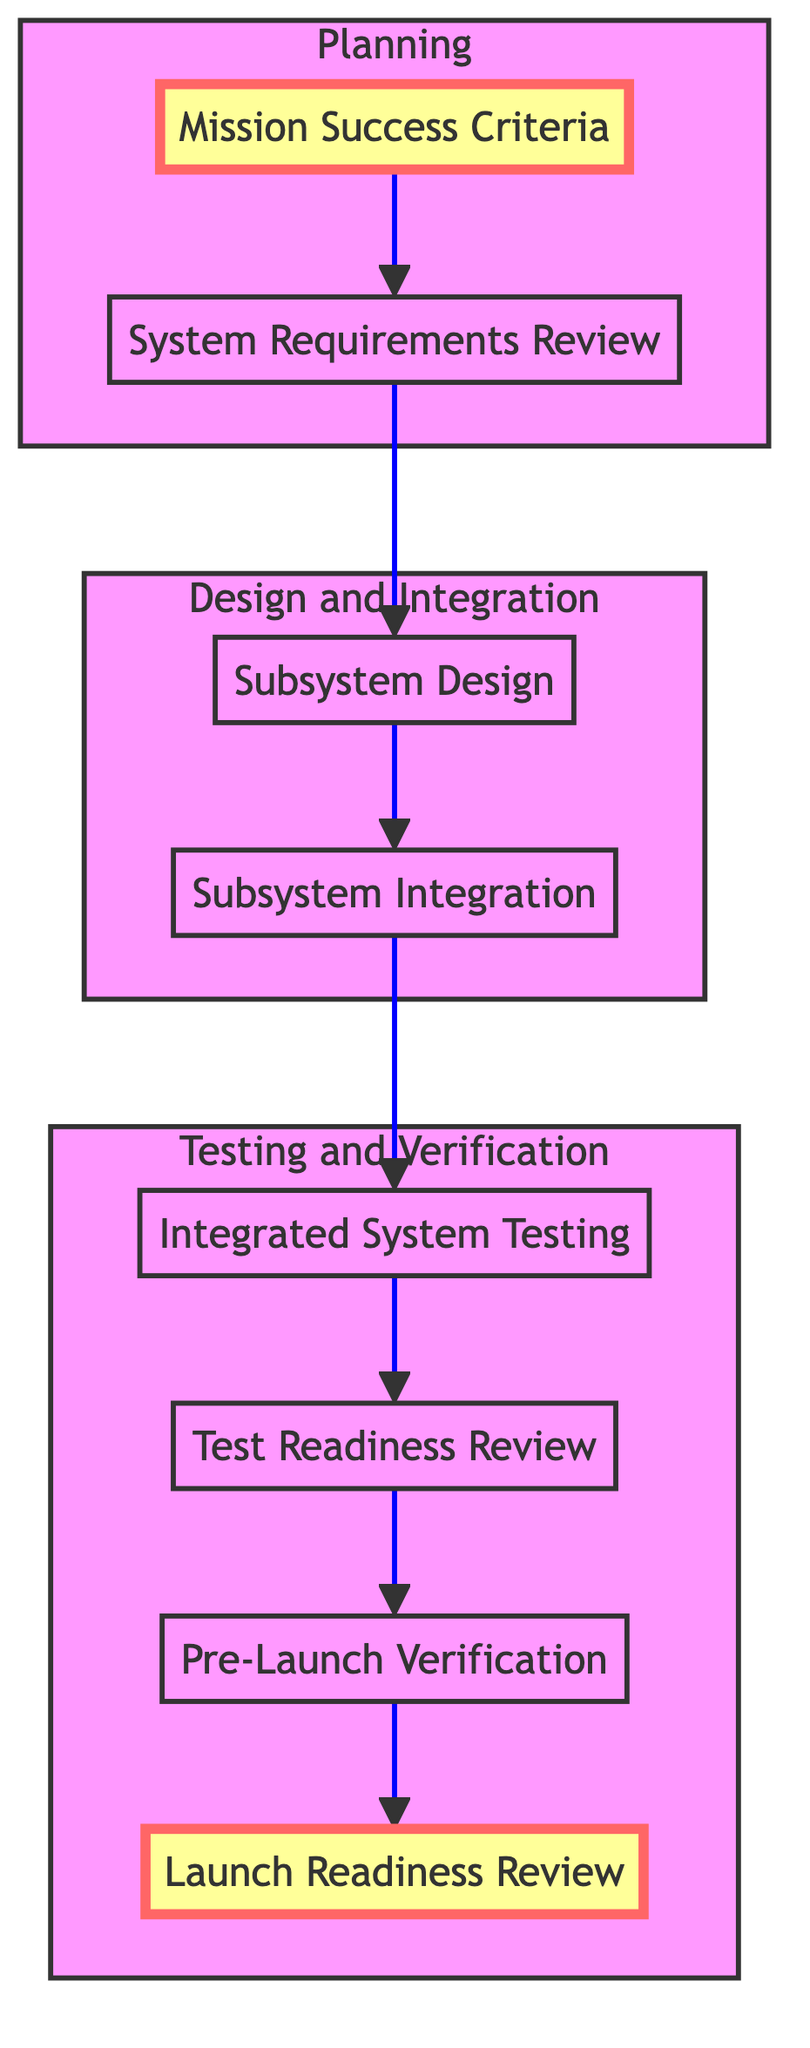What is the first step in the flowchart? The flowchart begins with the node labeled "Mission Success Criteria." Since it is the first element in the flowchart and has no predecessors, it initiates the process.
Answer: Mission Success Criteria How many total nodes are in the diagram? The diagram has a total of eight nodes, which represent different steps in the integration and testing process for the spacecraft. Counting each distinct labeled element from beginning to end yields this total.
Answer: Eight What node directly follows "Subsystem Design"? The node that directly follows "Subsystem Design" is "Subsystem Integration." This is confirmed by the directed flow from "Subsystem Design" to "Subsystem Integration" in the flowchart, indicating their sequential relationship.
Answer: Subsystem Integration Which step comes before "Test Readiness Review"? The step that comes immediately before "Test Readiness Review" is "Integrated System Testing." The directed edge pointing from "Integrated System Testing" to "Test Readiness Review" demonstrates their progression in the flow of the process.
Answer: Integrated System Testing What is the last step in the flowchart? The last step in the flowchart is "Launch Readiness Review." As indicated by the final node in the upward flow, this signifies the last assessment prior to launch.
Answer: Launch Readiness Review How many subgraph categories are in the diagram? The diagram is categorized into three subgraph sections: Planning, Design and Integration, and Testing and Verification. These groupings categorize the entire flow process into distinct phases.
Answer: Three What is the link style between the nodes? The link style between nodes is defined as a stroke-width of two pixels with no fill and a blue stroke. This graphical representation makes the connections between nodes clear and distinguishable.
Answer: Blue What step must be completed before "Pre-Launch Verification"? "Test Readiness Review" must be completed before "Pre-Launch Verification." The directed arrow from "Test Readiness Review" to "Pre-Launch Verification" indicates that it is a prerequisite in the process.
Answer: Test Readiness Review Which step integrates individual subsystems? The step that integrates individual subsystems is "Subsystem Integration." This node follows "Subsystem Design" and indicates the step of combining various subsystem designs into a single cohesive system.
Answer: Subsystem Integration 